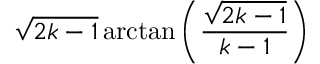Convert formula to latex. <formula><loc_0><loc_0><loc_500><loc_500>{ \sqrt { 2 k - 1 } } \arctan \left ( { \frac { \sqrt { 2 k - 1 } } { k - 1 } } \right )</formula> 